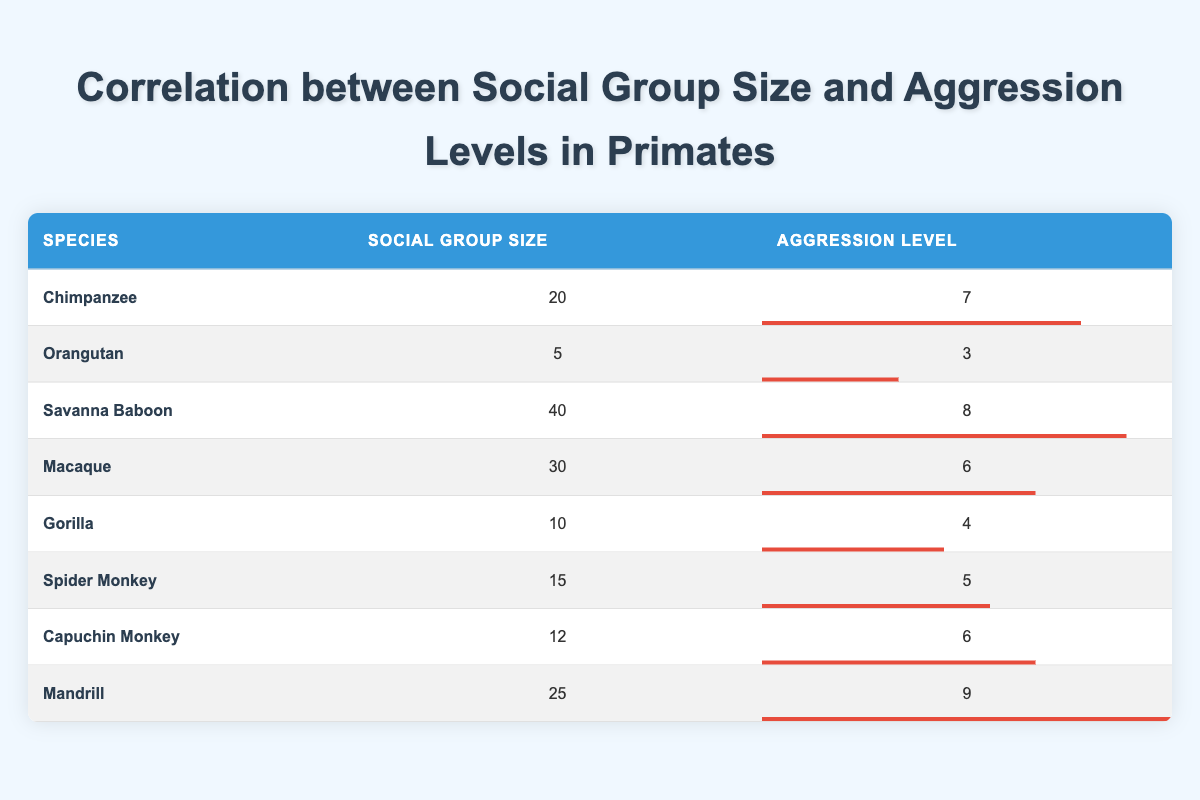What is the aggression level of the Chimpanzee? The table shows that the aggression level for the Chimpanzee is listed directly in the corresponding row under the Aggression Level column.
Answer: 7 What is the social group size of the Mandrill? The social group size for the Mandrill can be found directly in the table in the respective row under the Social Group Size column.
Answer: 25 Is the aggression level of the Orangutan higher than that of the Gorilla? Comparing the aggression levels from the table, the Orangutan has an aggression level of 3 while the Gorilla has an aggression level of 4. Since 3 is not higher than 4, the answer is no.
Answer: No What is the average social group size across all species listed in the table? To find the average, sum all the social group sizes: 20 + 5 + 40 + 30 + 10 + 15 + 12 + 25 = 157. There are 8 species, so the average is 157 divided by 8, which equals 19.625.
Answer: 19.625 Which species has the highest aggression level? By examining the Aggression Level column, we see that the Mandrill has the highest aggression level at 9.
Answer: Mandrill How much larger is the social group size of the Savanna Baboon compared to the Capuchin Monkey? The social group size of the Savanna Baboon is 40, and the Capuchin Monkey's size is 12. By subtracting 12 from 40, the difference is 28.
Answer: 28 Do more than half of the species have an aggression level of 6 or higher? The species with aggression levels of 6 or higher are Chimpanzee (7), Savanna Baboon (8), Macaque (6), Capuchin Monkey (6), and Mandrill (9). That totals 5 out of 8 species, which is more than half.
Answer: Yes If we exclude the species with the lowest aggression level, what would be the average aggression level of the remaining species? The species with the lowest aggression is the Orangutan (3). The remaining aggression levels are 7, 8, 6, 4, 5, 6, and 9. Summing these gives 7 + 8 + 6 + 4 + 5 + 6 + 9 = 45. There are 7 species left, so the average is 45 divided by 7, which equals approximately 6.43.
Answer: 6.43 